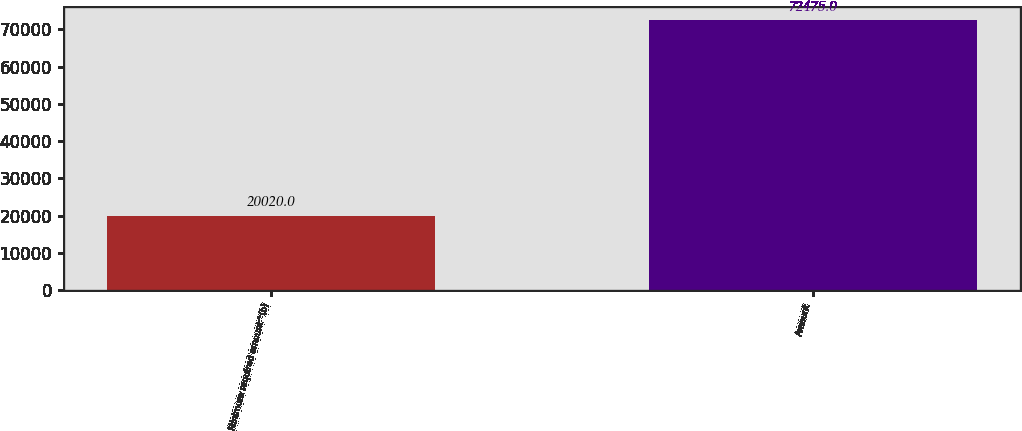Convert chart to OTSL. <chart><loc_0><loc_0><loc_500><loc_500><bar_chart><fcel>Minimum required amount^(b)<fcel>Amount<nl><fcel>20020<fcel>72475<nl></chart> 